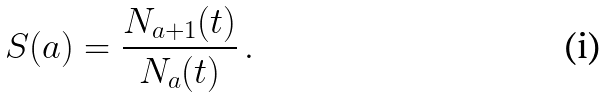<formula> <loc_0><loc_0><loc_500><loc_500>S ( a ) = \frac { N _ { a + 1 } ( t ) } { N _ { a } ( t ) } \, .</formula> 